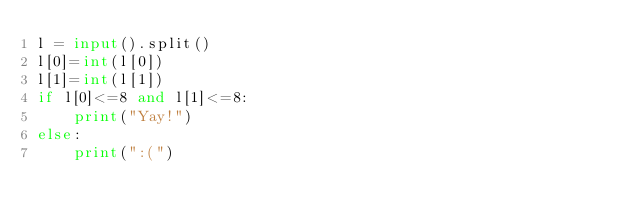<code> <loc_0><loc_0><loc_500><loc_500><_Python_>l = input().split()
l[0]=int(l[0])
l[1]=int(l[1])
if l[0]<=8 and l[1]<=8:
    print("Yay!")
else:
    print(":(")
    </code> 